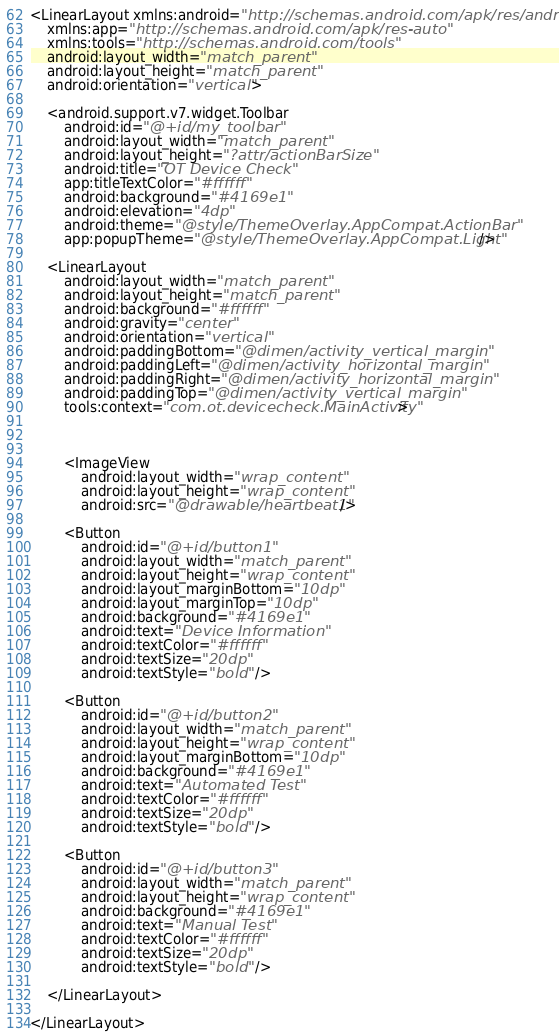Convert code to text. <code><loc_0><loc_0><loc_500><loc_500><_XML_><LinearLayout xmlns:android="http://schemas.android.com/apk/res/android"
    xmlns:app="http://schemas.android.com/apk/res-auto"
    xmlns:tools="http://schemas.android.com/tools"
    android:layout_width="match_parent"
    android:layout_height="match_parent"
    android:orientation="vertical">

    <android.support.v7.widget.Toolbar
        android:id="@+id/my_toolbar"
        android:layout_width="match_parent"
        android:layout_height="?attr/actionBarSize"
        android:title="OT Device Check"
        app:titleTextColor="#ffffff"
        android:background="#4169e1"
        android:elevation="4dp"
        android:theme="@style/ThemeOverlay.AppCompat.ActionBar"
        app:popupTheme="@style/ThemeOverlay.AppCompat.Light" />

    <LinearLayout
        android:layout_width="match_parent"
        android:layout_height="match_parent"
        android:background="#ffffff"
        android:gravity="center"
        android:orientation="vertical"
        android:paddingBottom="@dimen/activity_vertical_margin"
        android:paddingLeft="@dimen/activity_horizontal_margin"
        android:paddingRight="@dimen/activity_horizontal_margin"
        android:paddingTop="@dimen/activity_vertical_margin"
        tools:context="com.ot.devicecheck.MainActivity">



        <ImageView
            android:layout_width="wrap_content"
            android:layout_height="wrap_content"
            android:src="@drawable/heartbeat1" />

        <Button
            android:id="@+id/button1"
            android:layout_width="match_parent"
            android:layout_height="wrap_content"
            android:layout_marginBottom="10dp"
            android:layout_marginTop="10dp"
            android:background="#4169e1"
            android:text="Device Information"
            android:textColor="#ffffff"
            android:textSize="20dp"
            android:textStyle="bold" />

        <Button
            android:id="@+id/button2"
            android:layout_width="match_parent"
            android:layout_height="wrap_content"
            android:layout_marginBottom="10dp"
            android:background="#4169e1"
            android:text="Automated Test"
            android:textColor="#ffffff"
            android:textSize="20dp"
            android:textStyle="bold" />

        <Button
            android:id="@+id/button3"
            android:layout_width="match_parent"
            android:layout_height="wrap_content"
            android:background="#4169e1"
            android:text="Manual Test"
            android:textColor="#ffffff"
            android:textSize="20dp"
            android:textStyle="bold" />

    </LinearLayout>

</LinearLayout>
</code> 